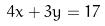Convert formula to latex. <formula><loc_0><loc_0><loc_500><loc_500>4 x + 3 y = 1 7</formula> 